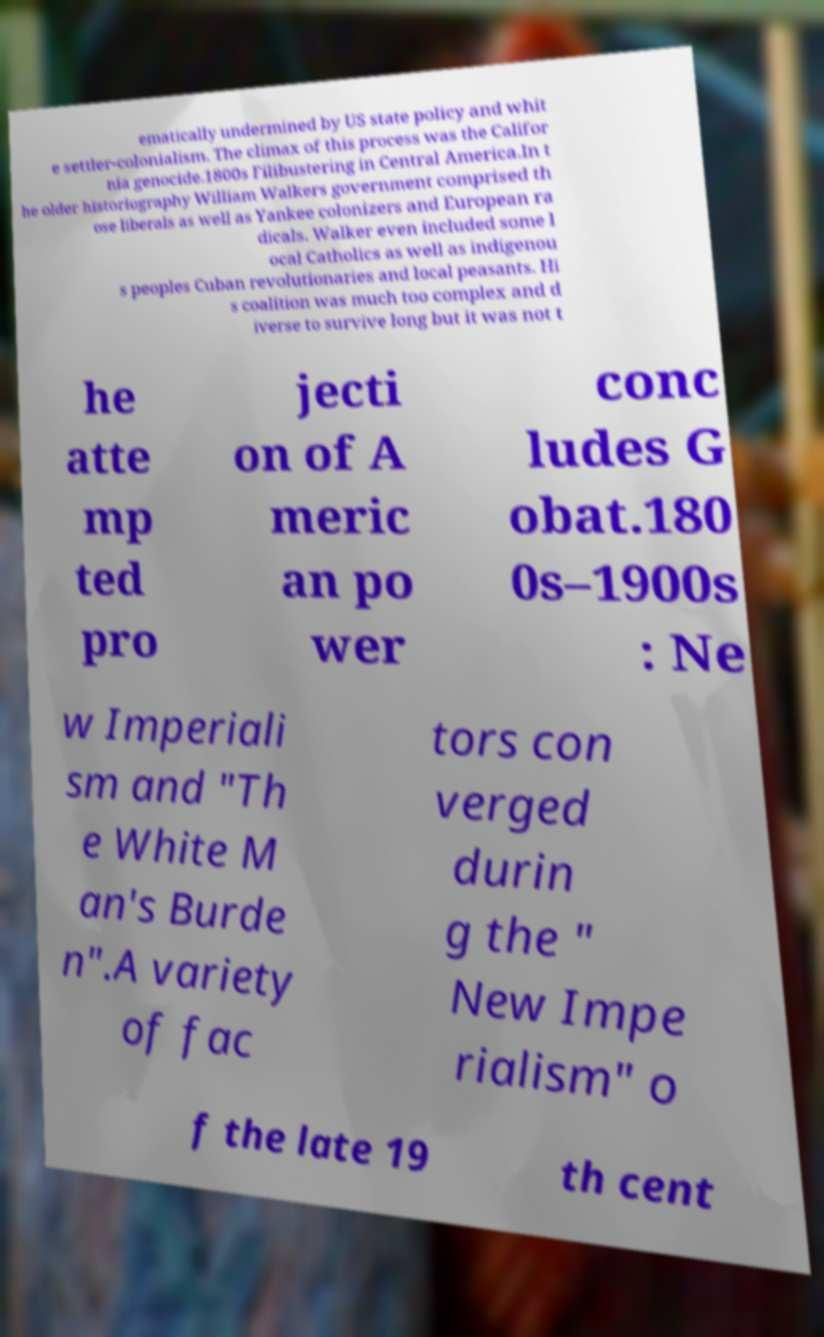Please identify and transcribe the text found in this image. ematically undermined by US state policy and whit e settler-colonialism. The climax of this process was the Califor nia genocide.1800s Filibustering in Central America.In t he older historiography William Walkers government comprised th ose liberals as well as Yankee colonizers and European ra dicals. Walker even included some l ocal Catholics as well as indigenou s peoples Cuban revolutionaries and local peasants. Hi s coalition was much too complex and d iverse to survive long but it was not t he atte mp ted pro jecti on of A meric an po wer conc ludes G obat.180 0s–1900s : Ne w Imperiali sm and "Th e White M an's Burde n".A variety of fac tors con verged durin g the " New Impe rialism" o f the late 19 th cent 